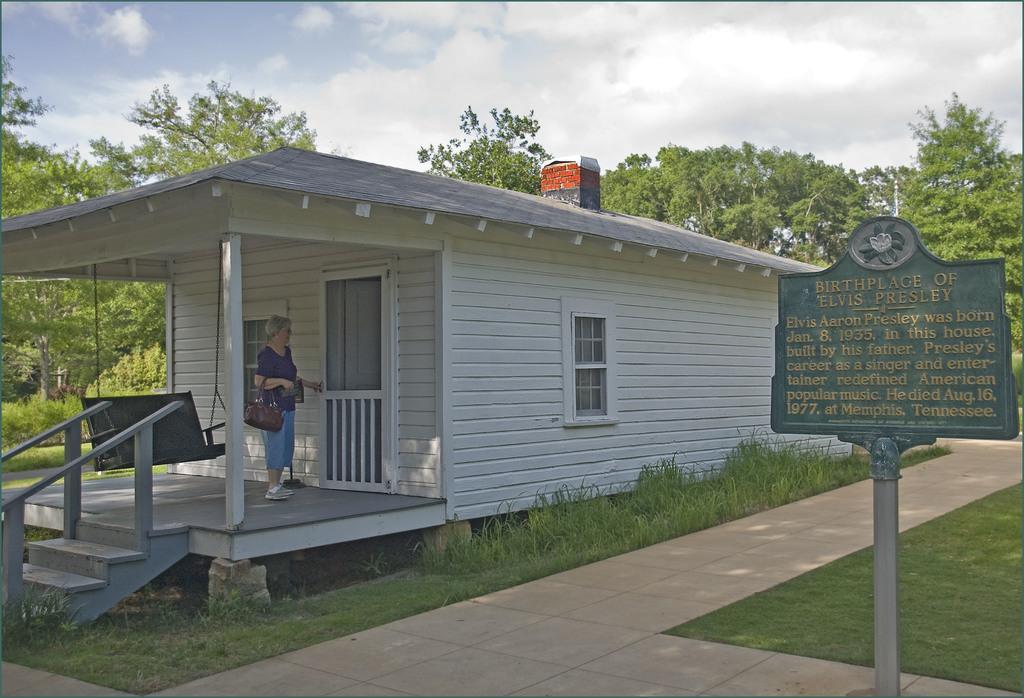How would you summarize this image in a sentence or two? In the picture there is a wooden house it is in white color and there is a woman standing in front of that house, behind her there is a cradle and there are plenty of trees around the area. 